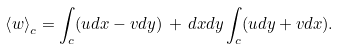<formula> <loc_0><loc_0><loc_500><loc_500>\left \langle w \right \rangle _ { c } = \int _ { c } ( u d x - v d y ) \, + \, d x d y \int _ { c } ( u d y + v d x ) .</formula> 